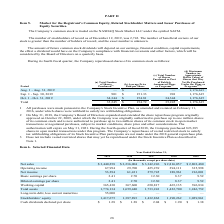According to Sanderson Farms's financial document, Which market is the company's common stock traded on? NASDAQ Stock Market LLC. The document states: "The Company’s common stock is traded on the NASDAQ Stock Market LLC under the symbol SAFM...." Also, What is the symbol of the company's common stock in the market? According to the financial document, SAFM. The relevant text states: "d on the NASDAQ Stock Market LLC under the symbol SAFM...." Also, What is the total number of shares purchased in the fourth fiscal quarter? According to the financial document, 35,245. The relevant text states: "Total 35,245 $ 154.72 35,245 1,176,615..." Also, can you calculate: What is the percentage constitution of the number of shares purchased in September 2019 among the total number of shares purchased in the fourth fiscal quarter? Based on the calculation: 901/35,245, the result is 2.56 (percentage). This is based on the information: "Sep. 1 - Sep. 30, 2019 901 $ 151.33 901 1,176,615 Total 35,245 $ 154.72 35,245 1,176,615..." The key data points involved are: 35,245, 901. Also, can you calculate: What is the difference in the total number of shares purchased between September 2019 and October 2019? Based on the calculation: 34,344-901, the result is 33443. This is based on the information: "Sep. 1 - Sep. 30, 2019 901 $ 151.33 901 1,176,615 Oct. 1 - Oct. 31, 2019 34,344 $ 154.81 34,344 1,176,615..." The key data points involved are: 34,344, 901. Also, can you calculate: What is the change in the average price paid per share between September 2019 and October 2019? Based on the calculation: 154.81-151.33, the result is 3.48. This is based on the information: "Oct. 1 - Oct. 31, 2019 34,344 $ 154.81 34,344 1,176,615 Sep. 1 - Sep. 30, 2019 901 $ 151.33 901 1,176,615..." The key data points involved are: 151.33, 154.81. 